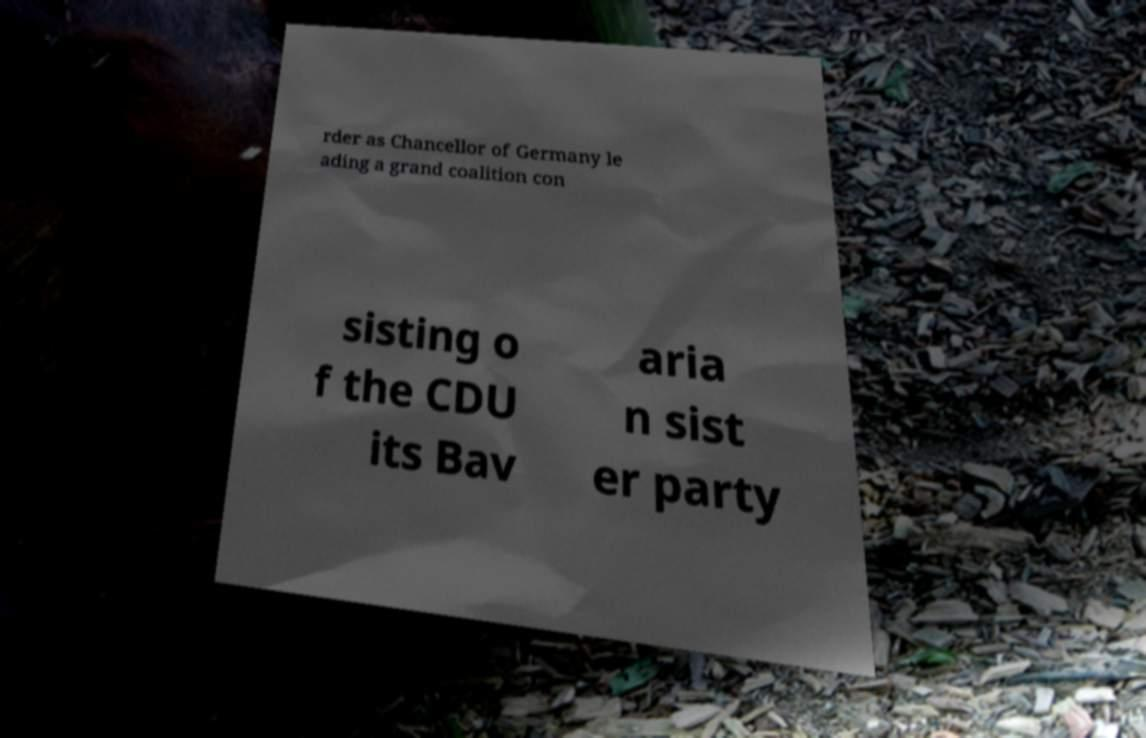For documentation purposes, I need the text within this image transcribed. Could you provide that? rder as Chancellor of Germany le ading a grand coalition con sisting o f the CDU its Bav aria n sist er party 